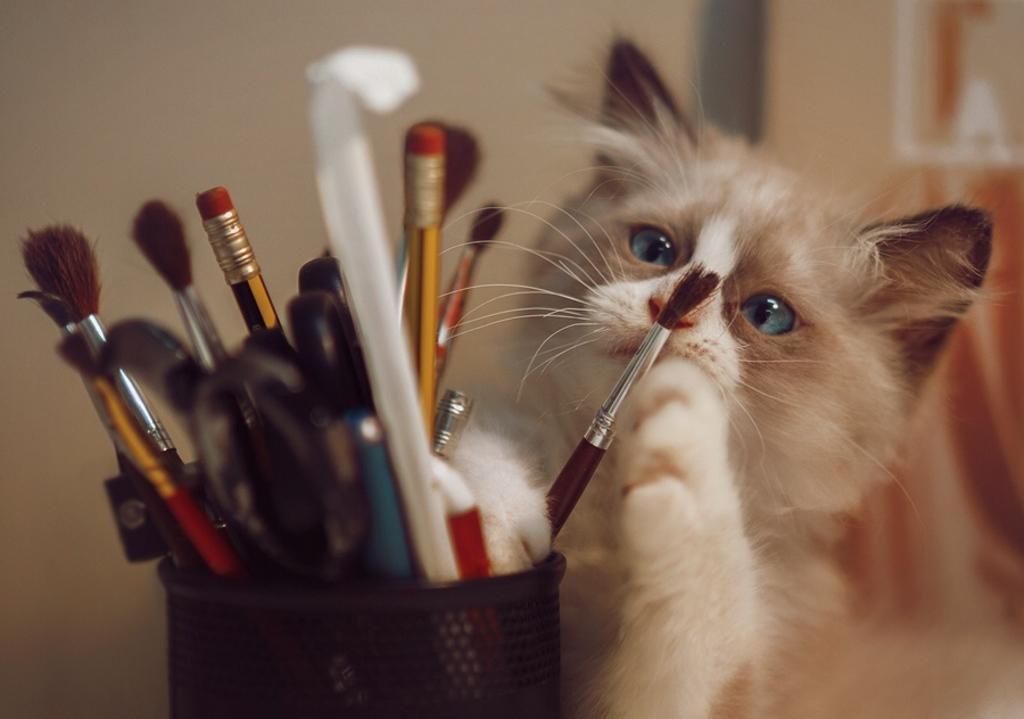In one or two sentences, can you explain what this image depicts? In this picture we can see few brushes, pencils and other things in the pen stand, in the background we can see a cat. 